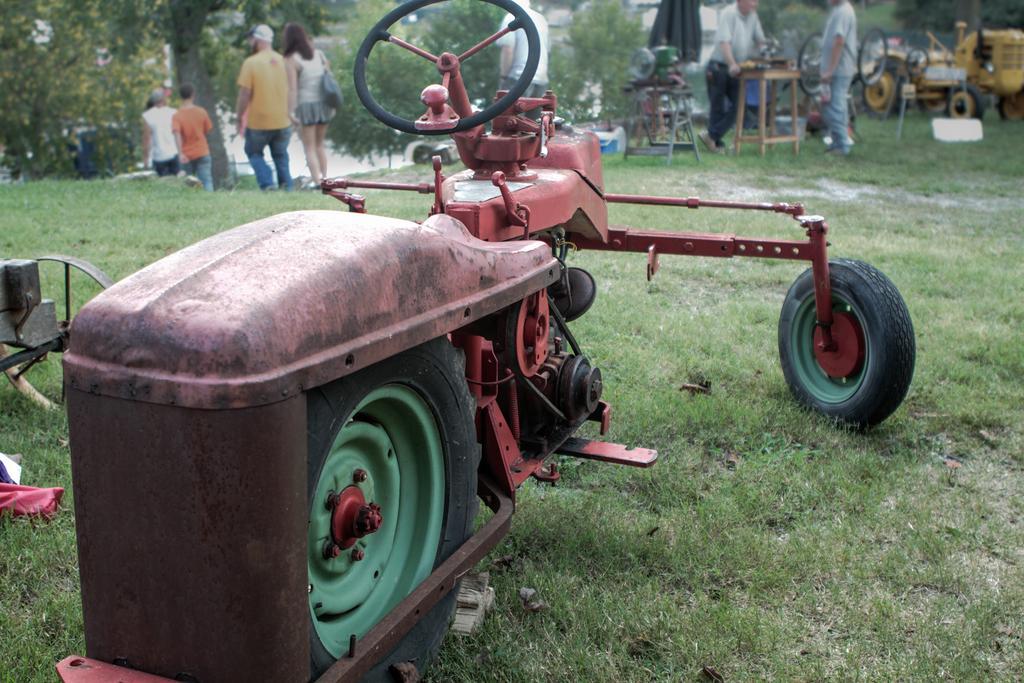In one or two sentences, can you explain what this image depicts? In this image we can see group of vehicles parked on the ground, group of persons is standing on the ground. In the background, we can see some machines placed on stands and a group of trees. 